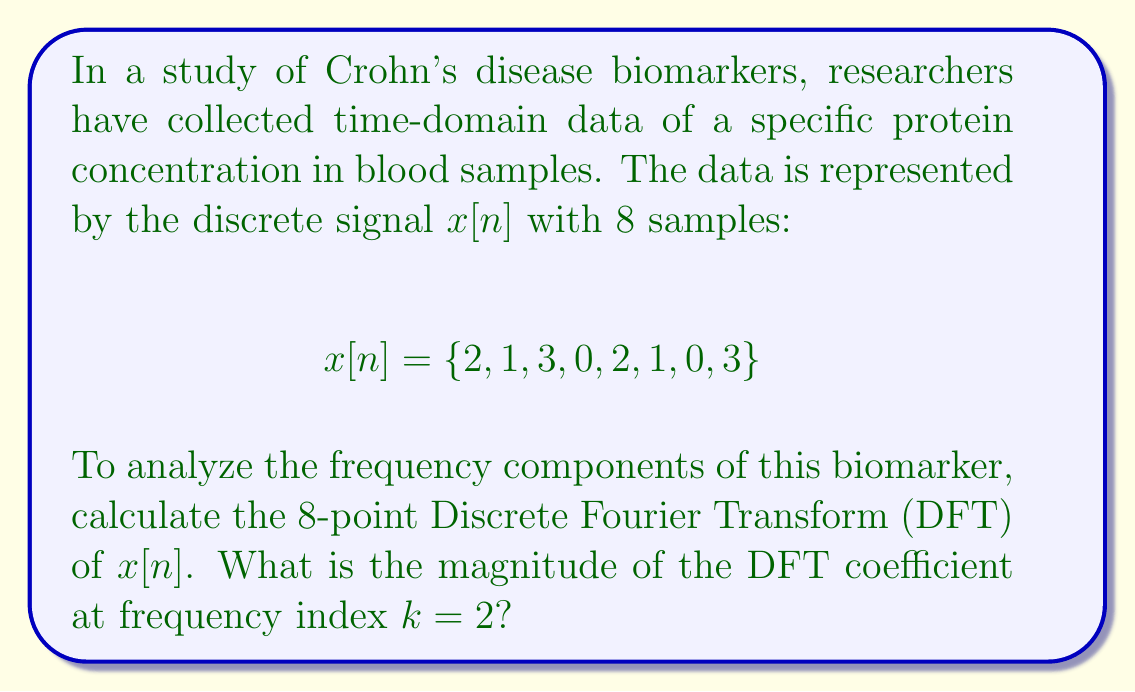Help me with this question. To solve this problem, we'll follow these steps:

1) The N-point DFT of a discrete signal $x[n]$ is given by:

   $$X[k] = \sum_{n=0}^{N-1} x[n] e^{-j2\pi kn/N}$$

   where $N=8$ in this case.

2) For $k=2$, we need to calculate:

   $$X[2] = \sum_{n=0}^{7} x[n] e^{-j2\pi 2n/8}$$

3) Expand this sum:

   $$X[2] = 2e^{-j0\pi} + 1e^{-j\pi/2} + 3e^{-j\pi} + 0e^{-j3\pi/2} + 2e^{-j2\pi} + 1e^{-j5\pi/2} + 0e^{-j3\pi} + 3e^{-j7\pi/2}$$

4) Simplify using Euler's formula ($e^{-j\theta} = \cos\theta - j\sin\theta$):

   $$X[2] = 2 + 1(-j) + 3(-1) + 0(j) + 2 + 1(j) + 0 + 3(-j)$$

5) Combine like terms:

   $$X[2] = (2 - 3 + 2) + (-1 - 3)j = 1 - 4j$$

6) The magnitude of a complex number $a + bj$ is given by $\sqrt{a^2 + b^2}$. Therefore:

   $$|X[2]| = \sqrt{1^2 + (-4)^2} = \sqrt{17}$$
Answer: The magnitude of the DFT coefficient at frequency index $k=2$ is $\sqrt{17}$. 